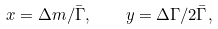<formula> <loc_0><loc_0><loc_500><loc_500>x = \Delta m / \bar { \Gamma } , \quad y = \Delta \Gamma / 2 \bar { \Gamma } ,</formula> 